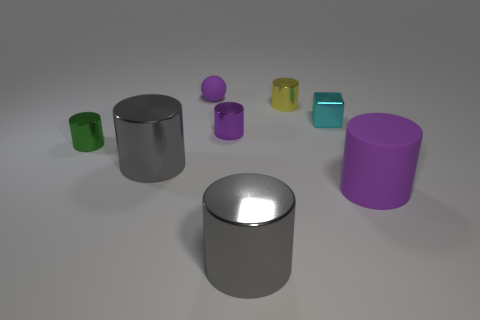What color is the other matte thing that is the same shape as the tiny green thing?
Your answer should be compact. Purple. What is the shape of the matte thing left of the purple shiny thing that is behind the purple matte thing in front of the tiny yellow cylinder?
Offer a very short reply. Sphere. Are there an equal number of cyan blocks to the left of the tiny cube and big gray things behind the small yellow shiny cylinder?
Offer a very short reply. Yes. There is a rubber thing that is the same size as the yellow cylinder; what color is it?
Your answer should be very brief. Purple. What number of tiny things are either matte cylinders or cubes?
Offer a terse response. 1. There is a purple thing that is in front of the tiny matte ball and behind the big purple thing; what is its material?
Provide a short and direct response. Metal. Does the large shiny object that is left of the small purple metallic cylinder have the same shape as the purple matte object that is to the right of the yellow cylinder?
Make the answer very short. Yes. There is a large rubber thing that is the same color as the tiny matte sphere; what shape is it?
Your response must be concise. Cylinder. How many objects are either matte things that are in front of the tiny yellow metallic thing or big gray metal cylinders?
Offer a terse response. 3. Is the yellow metallic cylinder the same size as the block?
Offer a very short reply. Yes. 